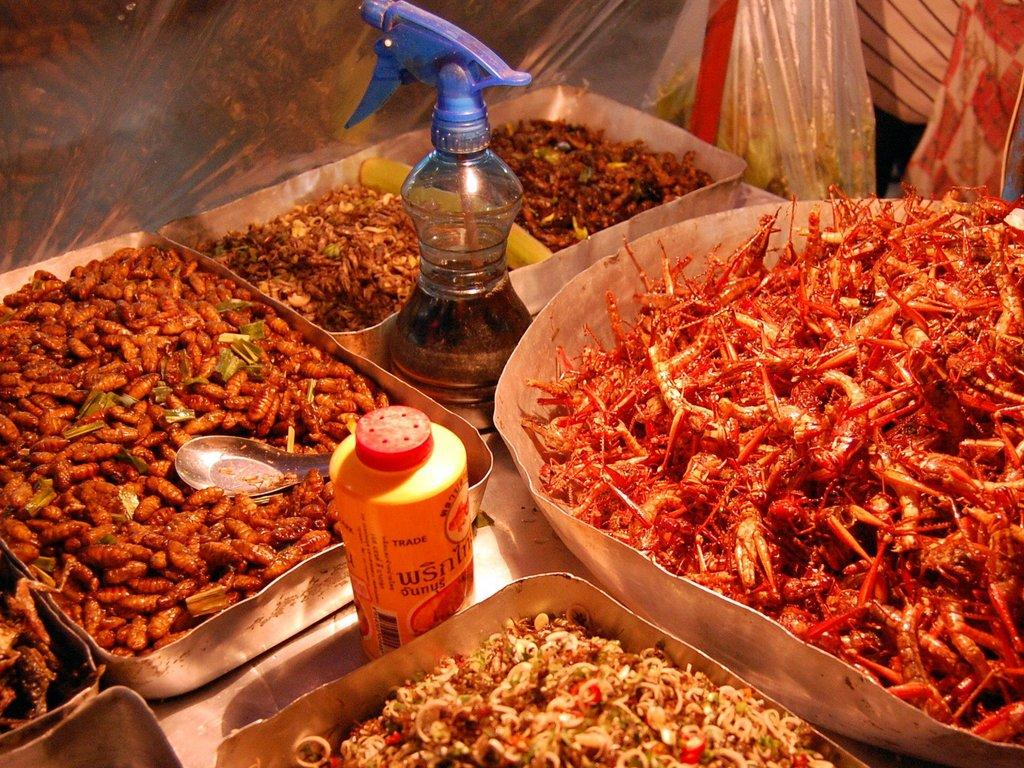What is on the plates in the image? There is food in the plates in the image. What is located beside the plates? There is a plastic cover beside the plates. What else can be seen in the image besides the plates and plastic cover? There are bottles in the image. How does the bear distribute the food in the image? There is no bear present in the image, so it cannot distribute the food. 